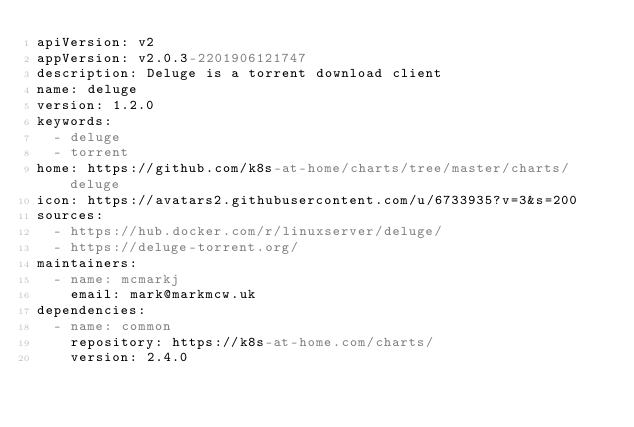Convert code to text. <code><loc_0><loc_0><loc_500><loc_500><_YAML_>apiVersion: v2
appVersion: v2.0.3-2201906121747
description: Deluge is a torrent download client
name: deluge
version: 1.2.0
keywords:
  - deluge
  - torrent
home: https://github.com/k8s-at-home/charts/tree/master/charts/deluge
icon: https://avatars2.githubusercontent.com/u/6733935?v=3&s=200
sources:
  - https://hub.docker.com/r/linuxserver/deluge/
  - https://deluge-torrent.org/
maintainers:
  - name: mcmarkj
    email: mark@markmcw.uk
dependencies:
  - name: common
    repository: https://k8s-at-home.com/charts/
    version: 2.4.0
</code> 